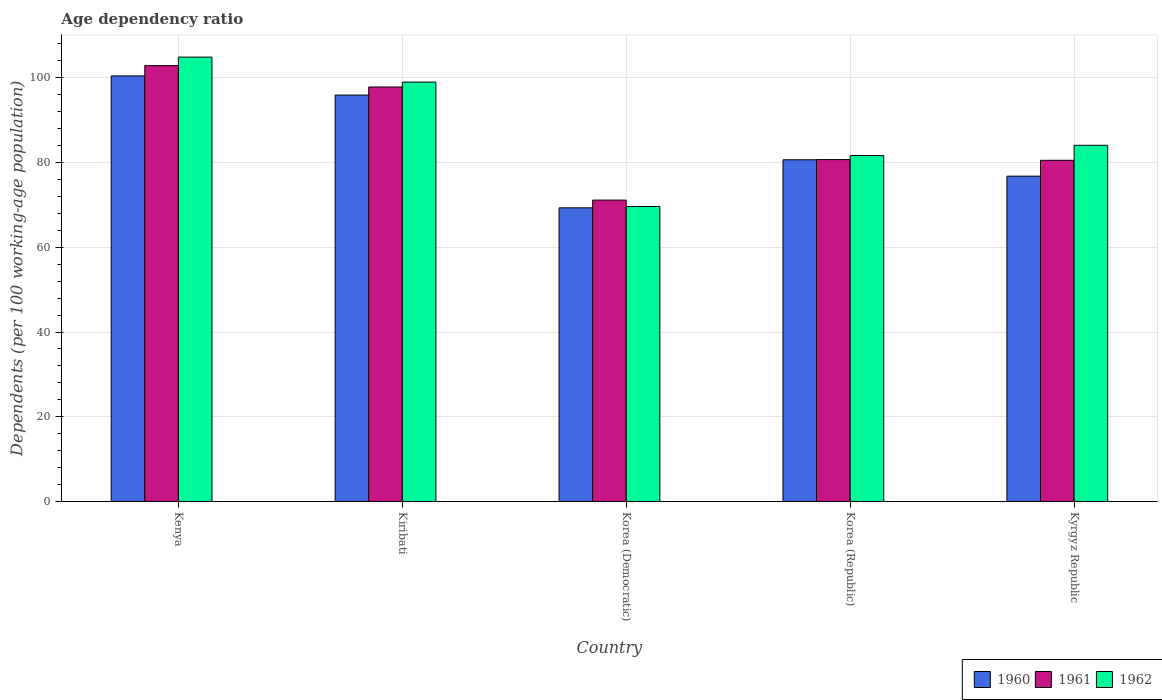How many different coloured bars are there?
Offer a terse response. 3. How many groups of bars are there?
Offer a very short reply. 5. Are the number of bars per tick equal to the number of legend labels?
Offer a terse response. Yes. How many bars are there on the 5th tick from the right?
Make the answer very short. 3. What is the label of the 3rd group of bars from the left?
Keep it short and to the point. Korea (Democratic). In how many cases, is the number of bars for a given country not equal to the number of legend labels?
Ensure brevity in your answer.  0. What is the age dependency ratio in in 1960 in Kenya?
Provide a succinct answer. 100.46. Across all countries, what is the maximum age dependency ratio in in 1960?
Your answer should be compact. 100.46. Across all countries, what is the minimum age dependency ratio in in 1961?
Make the answer very short. 71.15. In which country was the age dependency ratio in in 1960 maximum?
Your response must be concise. Kenya. In which country was the age dependency ratio in in 1960 minimum?
Ensure brevity in your answer.  Korea (Democratic). What is the total age dependency ratio in in 1960 in the graph?
Your answer should be very brief. 423.19. What is the difference between the age dependency ratio in in 1960 in Kenya and that in Korea (Democratic)?
Provide a short and direct response. 31.14. What is the difference between the age dependency ratio in in 1960 in Korea (Democratic) and the age dependency ratio in in 1962 in Kyrgyz Republic?
Make the answer very short. -14.77. What is the average age dependency ratio in in 1962 per country?
Your response must be concise. 87.86. What is the difference between the age dependency ratio in of/in 1961 and age dependency ratio in of/in 1962 in Korea (Republic)?
Offer a very short reply. -0.95. In how many countries, is the age dependency ratio in in 1961 greater than 60 %?
Offer a terse response. 5. What is the ratio of the age dependency ratio in in 1962 in Kenya to that in Kiribati?
Your answer should be very brief. 1.06. Is the difference between the age dependency ratio in in 1961 in Korea (Republic) and Kyrgyz Republic greater than the difference between the age dependency ratio in in 1962 in Korea (Republic) and Kyrgyz Republic?
Offer a very short reply. Yes. What is the difference between the highest and the second highest age dependency ratio in in 1962?
Provide a short and direct response. 5.9. What is the difference between the highest and the lowest age dependency ratio in in 1960?
Your answer should be compact. 31.14. In how many countries, is the age dependency ratio in in 1960 greater than the average age dependency ratio in in 1960 taken over all countries?
Provide a short and direct response. 2. What does the 1st bar from the left in Korea (Democratic) represents?
Keep it short and to the point. 1960. How many bars are there?
Your answer should be very brief. 15. Are all the bars in the graph horizontal?
Ensure brevity in your answer.  No. What is the difference between two consecutive major ticks on the Y-axis?
Your answer should be very brief. 20. Are the values on the major ticks of Y-axis written in scientific E-notation?
Offer a terse response. No. How many legend labels are there?
Your answer should be compact. 3. What is the title of the graph?
Your answer should be very brief. Age dependency ratio. What is the label or title of the Y-axis?
Your answer should be very brief. Dependents (per 100 working-age population). What is the Dependents (per 100 working-age population) in 1960 in Kenya?
Provide a succinct answer. 100.46. What is the Dependents (per 100 working-age population) in 1961 in Kenya?
Offer a very short reply. 102.89. What is the Dependents (per 100 working-age population) of 1962 in Kenya?
Provide a succinct answer. 104.91. What is the Dependents (per 100 working-age population) of 1960 in Kiribati?
Make the answer very short. 95.94. What is the Dependents (per 100 working-age population) in 1961 in Kiribati?
Make the answer very short. 97.85. What is the Dependents (per 100 working-age population) in 1962 in Kiribati?
Provide a short and direct response. 99.01. What is the Dependents (per 100 working-age population) in 1960 in Korea (Democratic)?
Your answer should be compact. 69.32. What is the Dependents (per 100 working-age population) of 1961 in Korea (Democratic)?
Your answer should be compact. 71.15. What is the Dependents (per 100 working-age population) in 1962 in Korea (Democratic)?
Provide a short and direct response. 69.63. What is the Dependents (per 100 working-age population) in 1960 in Korea (Republic)?
Your answer should be very brief. 80.67. What is the Dependents (per 100 working-age population) in 1961 in Korea (Republic)?
Your response must be concise. 80.71. What is the Dependents (per 100 working-age population) in 1962 in Korea (Republic)?
Provide a succinct answer. 81.67. What is the Dependents (per 100 working-age population) of 1960 in Kyrgyz Republic?
Make the answer very short. 76.8. What is the Dependents (per 100 working-age population) of 1961 in Kyrgyz Republic?
Give a very brief answer. 80.54. What is the Dependents (per 100 working-age population) in 1962 in Kyrgyz Republic?
Your response must be concise. 84.09. Across all countries, what is the maximum Dependents (per 100 working-age population) in 1960?
Provide a short and direct response. 100.46. Across all countries, what is the maximum Dependents (per 100 working-age population) of 1961?
Provide a succinct answer. 102.89. Across all countries, what is the maximum Dependents (per 100 working-age population) in 1962?
Keep it short and to the point. 104.91. Across all countries, what is the minimum Dependents (per 100 working-age population) of 1960?
Your answer should be very brief. 69.32. Across all countries, what is the minimum Dependents (per 100 working-age population) in 1961?
Your answer should be compact. 71.15. Across all countries, what is the minimum Dependents (per 100 working-age population) in 1962?
Make the answer very short. 69.63. What is the total Dependents (per 100 working-age population) in 1960 in the graph?
Keep it short and to the point. 423.19. What is the total Dependents (per 100 working-age population) in 1961 in the graph?
Your answer should be compact. 433.14. What is the total Dependents (per 100 working-age population) of 1962 in the graph?
Keep it short and to the point. 439.3. What is the difference between the Dependents (per 100 working-age population) of 1960 in Kenya and that in Kiribati?
Your answer should be compact. 4.52. What is the difference between the Dependents (per 100 working-age population) of 1961 in Kenya and that in Kiribati?
Give a very brief answer. 5.04. What is the difference between the Dependents (per 100 working-age population) in 1962 in Kenya and that in Kiribati?
Make the answer very short. 5.9. What is the difference between the Dependents (per 100 working-age population) of 1960 in Kenya and that in Korea (Democratic)?
Provide a succinct answer. 31.14. What is the difference between the Dependents (per 100 working-age population) in 1961 in Kenya and that in Korea (Democratic)?
Provide a succinct answer. 31.74. What is the difference between the Dependents (per 100 working-age population) of 1962 in Kenya and that in Korea (Democratic)?
Offer a terse response. 35.28. What is the difference between the Dependents (per 100 working-age population) of 1960 in Kenya and that in Korea (Republic)?
Give a very brief answer. 19.8. What is the difference between the Dependents (per 100 working-age population) of 1961 in Kenya and that in Korea (Republic)?
Provide a succinct answer. 22.18. What is the difference between the Dependents (per 100 working-age population) in 1962 in Kenya and that in Korea (Republic)?
Your answer should be very brief. 23.24. What is the difference between the Dependents (per 100 working-age population) of 1960 in Kenya and that in Kyrgyz Republic?
Provide a succinct answer. 23.66. What is the difference between the Dependents (per 100 working-age population) in 1961 in Kenya and that in Kyrgyz Republic?
Keep it short and to the point. 22.35. What is the difference between the Dependents (per 100 working-age population) of 1962 in Kenya and that in Kyrgyz Republic?
Keep it short and to the point. 20.82. What is the difference between the Dependents (per 100 working-age population) of 1960 in Kiribati and that in Korea (Democratic)?
Offer a very short reply. 26.62. What is the difference between the Dependents (per 100 working-age population) in 1961 in Kiribati and that in Korea (Democratic)?
Keep it short and to the point. 26.7. What is the difference between the Dependents (per 100 working-age population) in 1962 in Kiribati and that in Korea (Democratic)?
Provide a short and direct response. 29.38. What is the difference between the Dependents (per 100 working-age population) of 1960 in Kiribati and that in Korea (Republic)?
Ensure brevity in your answer.  15.28. What is the difference between the Dependents (per 100 working-age population) in 1961 in Kiribati and that in Korea (Republic)?
Ensure brevity in your answer.  17.14. What is the difference between the Dependents (per 100 working-age population) of 1962 in Kiribati and that in Korea (Republic)?
Make the answer very short. 17.34. What is the difference between the Dependents (per 100 working-age population) of 1960 in Kiribati and that in Kyrgyz Republic?
Offer a very short reply. 19.14. What is the difference between the Dependents (per 100 working-age population) of 1961 in Kiribati and that in Kyrgyz Republic?
Your answer should be very brief. 17.31. What is the difference between the Dependents (per 100 working-age population) in 1962 in Kiribati and that in Kyrgyz Republic?
Ensure brevity in your answer.  14.92. What is the difference between the Dependents (per 100 working-age population) in 1960 in Korea (Democratic) and that in Korea (Republic)?
Ensure brevity in your answer.  -11.34. What is the difference between the Dependents (per 100 working-age population) in 1961 in Korea (Democratic) and that in Korea (Republic)?
Offer a very short reply. -9.56. What is the difference between the Dependents (per 100 working-age population) of 1962 in Korea (Democratic) and that in Korea (Republic)?
Keep it short and to the point. -12.03. What is the difference between the Dependents (per 100 working-age population) of 1960 in Korea (Democratic) and that in Kyrgyz Republic?
Offer a very short reply. -7.48. What is the difference between the Dependents (per 100 working-age population) in 1961 in Korea (Democratic) and that in Kyrgyz Republic?
Your answer should be very brief. -9.4. What is the difference between the Dependents (per 100 working-age population) of 1962 in Korea (Democratic) and that in Kyrgyz Republic?
Ensure brevity in your answer.  -14.46. What is the difference between the Dependents (per 100 working-age population) in 1960 in Korea (Republic) and that in Kyrgyz Republic?
Give a very brief answer. 3.86. What is the difference between the Dependents (per 100 working-age population) in 1961 in Korea (Republic) and that in Kyrgyz Republic?
Your response must be concise. 0.17. What is the difference between the Dependents (per 100 working-age population) in 1962 in Korea (Republic) and that in Kyrgyz Republic?
Ensure brevity in your answer.  -2.43. What is the difference between the Dependents (per 100 working-age population) in 1960 in Kenya and the Dependents (per 100 working-age population) in 1961 in Kiribati?
Your answer should be very brief. 2.61. What is the difference between the Dependents (per 100 working-age population) in 1960 in Kenya and the Dependents (per 100 working-age population) in 1962 in Kiribati?
Provide a short and direct response. 1.46. What is the difference between the Dependents (per 100 working-age population) of 1961 in Kenya and the Dependents (per 100 working-age population) of 1962 in Kiribati?
Offer a very short reply. 3.88. What is the difference between the Dependents (per 100 working-age population) of 1960 in Kenya and the Dependents (per 100 working-age population) of 1961 in Korea (Democratic)?
Keep it short and to the point. 29.32. What is the difference between the Dependents (per 100 working-age population) of 1960 in Kenya and the Dependents (per 100 working-age population) of 1962 in Korea (Democratic)?
Provide a succinct answer. 30.83. What is the difference between the Dependents (per 100 working-age population) in 1961 in Kenya and the Dependents (per 100 working-age population) in 1962 in Korea (Democratic)?
Provide a succinct answer. 33.26. What is the difference between the Dependents (per 100 working-age population) of 1960 in Kenya and the Dependents (per 100 working-age population) of 1961 in Korea (Republic)?
Offer a very short reply. 19.75. What is the difference between the Dependents (per 100 working-age population) in 1960 in Kenya and the Dependents (per 100 working-age population) in 1962 in Korea (Republic)?
Your response must be concise. 18.8. What is the difference between the Dependents (per 100 working-age population) in 1961 in Kenya and the Dependents (per 100 working-age population) in 1962 in Korea (Republic)?
Offer a terse response. 21.22. What is the difference between the Dependents (per 100 working-age population) of 1960 in Kenya and the Dependents (per 100 working-age population) of 1961 in Kyrgyz Republic?
Offer a very short reply. 19.92. What is the difference between the Dependents (per 100 working-age population) in 1960 in Kenya and the Dependents (per 100 working-age population) in 1962 in Kyrgyz Republic?
Make the answer very short. 16.37. What is the difference between the Dependents (per 100 working-age population) in 1961 in Kenya and the Dependents (per 100 working-age population) in 1962 in Kyrgyz Republic?
Offer a very short reply. 18.8. What is the difference between the Dependents (per 100 working-age population) of 1960 in Kiribati and the Dependents (per 100 working-age population) of 1961 in Korea (Democratic)?
Your response must be concise. 24.79. What is the difference between the Dependents (per 100 working-age population) in 1960 in Kiribati and the Dependents (per 100 working-age population) in 1962 in Korea (Democratic)?
Make the answer very short. 26.31. What is the difference between the Dependents (per 100 working-age population) in 1961 in Kiribati and the Dependents (per 100 working-age population) in 1962 in Korea (Democratic)?
Your response must be concise. 28.22. What is the difference between the Dependents (per 100 working-age population) of 1960 in Kiribati and the Dependents (per 100 working-age population) of 1961 in Korea (Republic)?
Keep it short and to the point. 15.23. What is the difference between the Dependents (per 100 working-age population) in 1960 in Kiribati and the Dependents (per 100 working-age population) in 1962 in Korea (Republic)?
Provide a succinct answer. 14.28. What is the difference between the Dependents (per 100 working-age population) of 1961 in Kiribati and the Dependents (per 100 working-age population) of 1962 in Korea (Republic)?
Offer a terse response. 16.19. What is the difference between the Dependents (per 100 working-age population) in 1960 in Kiribati and the Dependents (per 100 working-age population) in 1961 in Kyrgyz Republic?
Give a very brief answer. 15.4. What is the difference between the Dependents (per 100 working-age population) in 1960 in Kiribati and the Dependents (per 100 working-age population) in 1962 in Kyrgyz Republic?
Make the answer very short. 11.85. What is the difference between the Dependents (per 100 working-age population) of 1961 in Kiribati and the Dependents (per 100 working-age population) of 1962 in Kyrgyz Republic?
Ensure brevity in your answer.  13.76. What is the difference between the Dependents (per 100 working-age population) of 1960 in Korea (Democratic) and the Dependents (per 100 working-age population) of 1961 in Korea (Republic)?
Your answer should be compact. -11.39. What is the difference between the Dependents (per 100 working-age population) of 1960 in Korea (Democratic) and the Dependents (per 100 working-age population) of 1962 in Korea (Republic)?
Your answer should be very brief. -12.34. What is the difference between the Dependents (per 100 working-age population) in 1961 in Korea (Democratic) and the Dependents (per 100 working-age population) in 1962 in Korea (Republic)?
Give a very brief answer. -10.52. What is the difference between the Dependents (per 100 working-age population) in 1960 in Korea (Democratic) and the Dependents (per 100 working-age population) in 1961 in Kyrgyz Republic?
Your answer should be very brief. -11.22. What is the difference between the Dependents (per 100 working-age population) in 1960 in Korea (Democratic) and the Dependents (per 100 working-age population) in 1962 in Kyrgyz Republic?
Make the answer very short. -14.77. What is the difference between the Dependents (per 100 working-age population) in 1961 in Korea (Democratic) and the Dependents (per 100 working-age population) in 1962 in Kyrgyz Republic?
Make the answer very short. -12.94. What is the difference between the Dependents (per 100 working-age population) in 1960 in Korea (Republic) and the Dependents (per 100 working-age population) in 1961 in Kyrgyz Republic?
Your response must be concise. 0.12. What is the difference between the Dependents (per 100 working-age population) in 1960 in Korea (Republic) and the Dependents (per 100 working-age population) in 1962 in Kyrgyz Republic?
Ensure brevity in your answer.  -3.42. What is the difference between the Dependents (per 100 working-age population) of 1961 in Korea (Republic) and the Dependents (per 100 working-age population) of 1962 in Kyrgyz Republic?
Ensure brevity in your answer.  -3.38. What is the average Dependents (per 100 working-age population) of 1960 per country?
Your response must be concise. 84.64. What is the average Dependents (per 100 working-age population) in 1961 per country?
Your answer should be compact. 86.63. What is the average Dependents (per 100 working-age population) of 1962 per country?
Offer a terse response. 87.86. What is the difference between the Dependents (per 100 working-age population) of 1960 and Dependents (per 100 working-age population) of 1961 in Kenya?
Provide a short and direct response. -2.42. What is the difference between the Dependents (per 100 working-age population) in 1960 and Dependents (per 100 working-age population) in 1962 in Kenya?
Make the answer very short. -4.44. What is the difference between the Dependents (per 100 working-age population) in 1961 and Dependents (per 100 working-age population) in 1962 in Kenya?
Give a very brief answer. -2.02. What is the difference between the Dependents (per 100 working-age population) of 1960 and Dependents (per 100 working-age population) of 1961 in Kiribati?
Offer a very short reply. -1.91. What is the difference between the Dependents (per 100 working-age population) in 1960 and Dependents (per 100 working-age population) in 1962 in Kiribati?
Your answer should be very brief. -3.07. What is the difference between the Dependents (per 100 working-age population) in 1961 and Dependents (per 100 working-age population) in 1962 in Kiribati?
Provide a short and direct response. -1.16. What is the difference between the Dependents (per 100 working-age population) in 1960 and Dependents (per 100 working-age population) in 1961 in Korea (Democratic)?
Offer a very short reply. -1.83. What is the difference between the Dependents (per 100 working-age population) of 1960 and Dependents (per 100 working-age population) of 1962 in Korea (Democratic)?
Your answer should be compact. -0.31. What is the difference between the Dependents (per 100 working-age population) of 1961 and Dependents (per 100 working-age population) of 1962 in Korea (Democratic)?
Your answer should be very brief. 1.52. What is the difference between the Dependents (per 100 working-age population) in 1960 and Dependents (per 100 working-age population) in 1961 in Korea (Republic)?
Provide a succinct answer. -0.05. What is the difference between the Dependents (per 100 working-age population) of 1960 and Dependents (per 100 working-age population) of 1962 in Korea (Republic)?
Make the answer very short. -1. What is the difference between the Dependents (per 100 working-age population) of 1961 and Dependents (per 100 working-age population) of 1962 in Korea (Republic)?
Your answer should be compact. -0.95. What is the difference between the Dependents (per 100 working-age population) of 1960 and Dependents (per 100 working-age population) of 1961 in Kyrgyz Republic?
Give a very brief answer. -3.74. What is the difference between the Dependents (per 100 working-age population) in 1960 and Dependents (per 100 working-age population) in 1962 in Kyrgyz Republic?
Offer a terse response. -7.29. What is the difference between the Dependents (per 100 working-age population) of 1961 and Dependents (per 100 working-age population) of 1962 in Kyrgyz Republic?
Offer a very short reply. -3.55. What is the ratio of the Dependents (per 100 working-age population) of 1960 in Kenya to that in Kiribati?
Ensure brevity in your answer.  1.05. What is the ratio of the Dependents (per 100 working-age population) in 1961 in Kenya to that in Kiribati?
Provide a short and direct response. 1.05. What is the ratio of the Dependents (per 100 working-age population) in 1962 in Kenya to that in Kiribati?
Provide a short and direct response. 1.06. What is the ratio of the Dependents (per 100 working-age population) in 1960 in Kenya to that in Korea (Democratic)?
Give a very brief answer. 1.45. What is the ratio of the Dependents (per 100 working-age population) in 1961 in Kenya to that in Korea (Democratic)?
Provide a succinct answer. 1.45. What is the ratio of the Dependents (per 100 working-age population) of 1962 in Kenya to that in Korea (Democratic)?
Provide a succinct answer. 1.51. What is the ratio of the Dependents (per 100 working-age population) of 1960 in Kenya to that in Korea (Republic)?
Your answer should be compact. 1.25. What is the ratio of the Dependents (per 100 working-age population) in 1961 in Kenya to that in Korea (Republic)?
Offer a terse response. 1.27. What is the ratio of the Dependents (per 100 working-age population) of 1962 in Kenya to that in Korea (Republic)?
Your answer should be very brief. 1.28. What is the ratio of the Dependents (per 100 working-age population) in 1960 in Kenya to that in Kyrgyz Republic?
Your answer should be compact. 1.31. What is the ratio of the Dependents (per 100 working-age population) in 1961 in Kenya to that in Kyrgyz Republic?
Keep it short and to the point. 1.28. What is the ratio of the Dependents (per 100 working-age population) in 1962 in Kenya to that in Kyrgyz Republic?
Your answer should be compact. 1.25. What is the ratio of the Dependents (per 100 working-age population) of 1960 in Kiribati to that in Korea (Democratic)?
Give a very brief answer. 1.38. What is the ratio of the Dependents (per 100 working-age population) of 1961 in Kiribati to that in Korea (Democratic)?
Provide a succinct answer. 1.38. What is the ratio of the Dependents (per 100 working-age population) in 1962 in Kiribati to that in Korea (Democratic)?
Offer a very short reply. 1.42. What is the ratio of the Dependents (per 100 working-age population) in 1960 in Kiribati to that in Korea (Republic)?
Ensure brevity in your answer.  1.19. What is the ratio of the Dependents (per 100 working-age population) of 1961 in Kiribati to that in Korea (Republic)?
Give a very brief answer. 1.21. What is the ratio of the Dependents (per 100 working-age population) in 1962 in Kiribati to that in Korea (Republic)?
Make the answer very short. 1.21. What is the ratio of the Dependents (per 100 working-age population) in 1960 in Kiribati to that in Kyrgyz Republic?
Your response must be concise. 1.25. What is the ratio of the Dependents (per 100 working-age population) in 1961 in Kiribati to that in Kyrgyz Republic?
Your response must be concise. 1.21. What is the ratio of the Dependents (per 100 working-age population) of 1962 in Kiribati to that in Kyrgyz Republic?
Provide a succinct answer. 1.18. What is the ratio of the Dependents (per 100 working-age population) in 1960 in Korea (Democratic) to that in Korea (Republic)?
Provide a succinct answer. 0.86. What is the ratio of the Dependents (per 100 working-age population) of 1961 in Korea (Democratic) to that in Korea (Republic)?
Provide a short and direct response. 0.88. What is the ratio of the Dependents (per 100 working-age population) in 1962 in Korea (Democratic) to that in Korea (Republic)?
Make the answer very short. 0.85. What is the ratio of the Dependents (per 100 working-age population) of 1960 in Korea (Democratic) to that in Kyrgyz Republic?
Your answer should be very brief. 0.9. What is the ratio of the Dependents (per 100 working-age population) of 1961 in Korea (Democratic) to that in Kyrgyz Republic?
Your answer should be very brief. 0.88. What is the ratio of the Dependents (per 100 working-age population) in 1962 in Korea (Democratic) to that in Kyrgyz Republic?
Make the answer very short. 0.83. What is the ratio of the Dependents (per 100 working-age population) in 1960 in Korea (Republic) to that in Kyrgyz Republic?
Provide a succinct answer. 1.05. What is the ratio of the Dependents (per 100 working-age population) of 1961 in Korea (Republic) to that in Kyrgyz Republic?
Keep it short and to the point. 1. What is the ratio of the Dependents (per 100 working-age population) of 1962 in Korea (Republic) to that in Kyrgyz Republic?
Keep it short and to the point. 0.97. What is the difference between the highest and the second highest Dependents (per 100 working-age population) in 1960?
Ensure brevity in your answer.  4.52. What is the difference between the highest and the second highest Dependents (per 100 working-age population) in 1961?
Your answer should be very brief. 5.04. What is the difference between the highest and the second highest Dependents (per 100 working-age population) of 1962?
Give a very brief answer. 5.9. What is the difference between the highest and the lowest Dependents (per 100 working-age population) of 1960?
Make the answer very short. 31.14. What is the difference between the highest and the lowest Dependents (per 100 working-age population) of 1961?
Offer a terse response. 31.74. What is the difference between the highest and the lowest Dependents (per 100 working-age population) in 1962?
Your answer should be very brief. 35.28. 